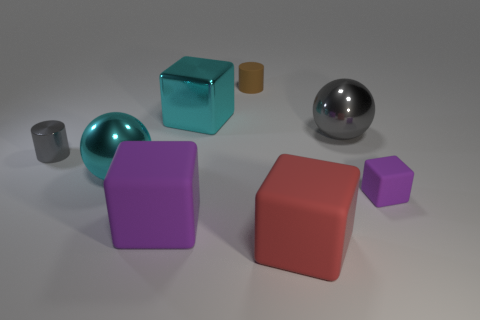Are there fewer large gray balls that are right of the small block than tiny purple things to the right of the red object?
Offer a terse response. Yes. What number of objects are either gray metal objects or brown rubber objects?
Give a very brief answer. 3. How many large purple objects are behind the big shiny cube?
Offer a terse response. 0. Is the color of the tiny matte cylinder the same as the tiny metallic cylinder?
Offer a very short reply. No. There is a tiny object that is the same material as the small brown cylinder; what is its shape?
Your answer should be very brief. Cube. Does the brown rubber object on the left side of the large gray ball have the same shape as the small purple object?
Offer a very short reply. No. How many red objects are big rubber cubes or large objects?
Give a very brief answer. 1. Are there an equal number of tiny purple things behind the gray metal cylinder and red objects to the right of the red cube?
Your answer should be compact. Yes. What is the color of the tiny matte object that is in front of the shiny sphere right of the big rubber object to the left of the matte cylinder?
Your answer should be compact. Purple. Is there anything else that is the same color as the small matte cube?
Make the answer very short. Yes. 